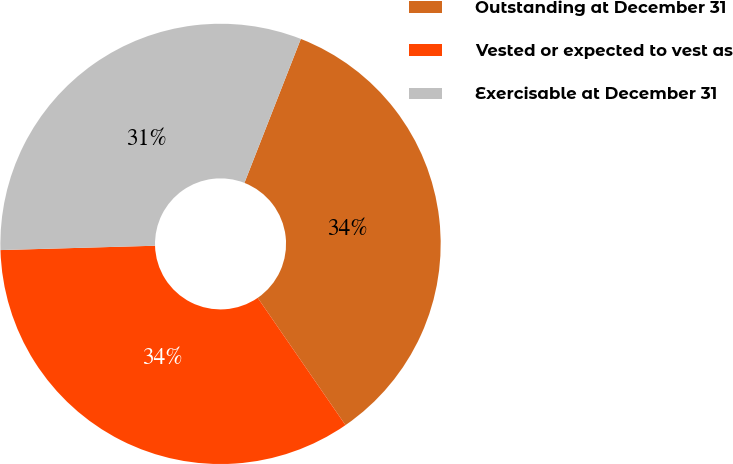Convert chart to OTSL. <chart><loc_0><loc_0><loc_500><loc_500><pie_chart><fcel>Outstanding at December 31<fcel>Vested or expected to vest as<fcel>Exercisable at December 31<nl><fcel>34.45%<fcel>34.16%<fcel>31.39%<nl></chart> 